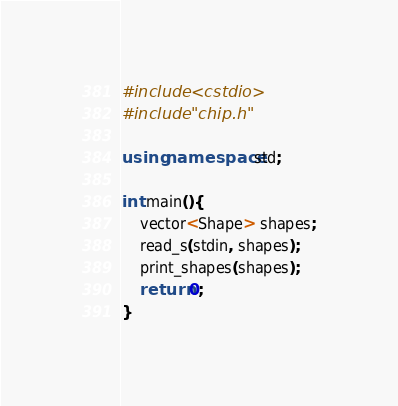Convert code to text. <code><loc_0><loc_0><loc_500><loc_500><_C++_>#include <cstdio>
#include "chip.h"

using namespace std;

int main(){
    vector<Shape> shapes;
    read_s(stdin, shapes);
    print_shapes(shapes);
    return 0;
}
</code> 